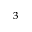Convert formula to latex. <formula><loc_0><loc_0><loc_500><loc_500>^ { 3 }</formula> 